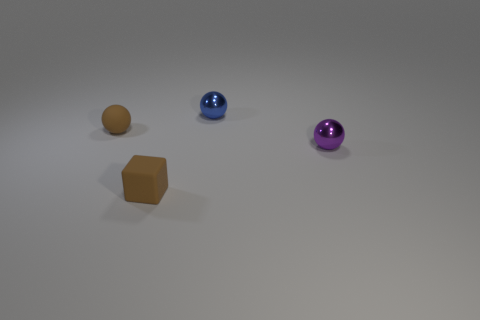Add 2 tiny blue shiny objects. How many objects exist? 6 Subtract all spheres. How many objects are left? 1 Subtract 0 red blocks. How many objects are left? 4 Subtract all brown objects. Subtract all small rubber cubes. How many objects are left? 1 Add 4 blue things. How many blue things are left? 5 Add 2 tiny brown matte spheres. How many tiny brown matte spheres exist? 3 